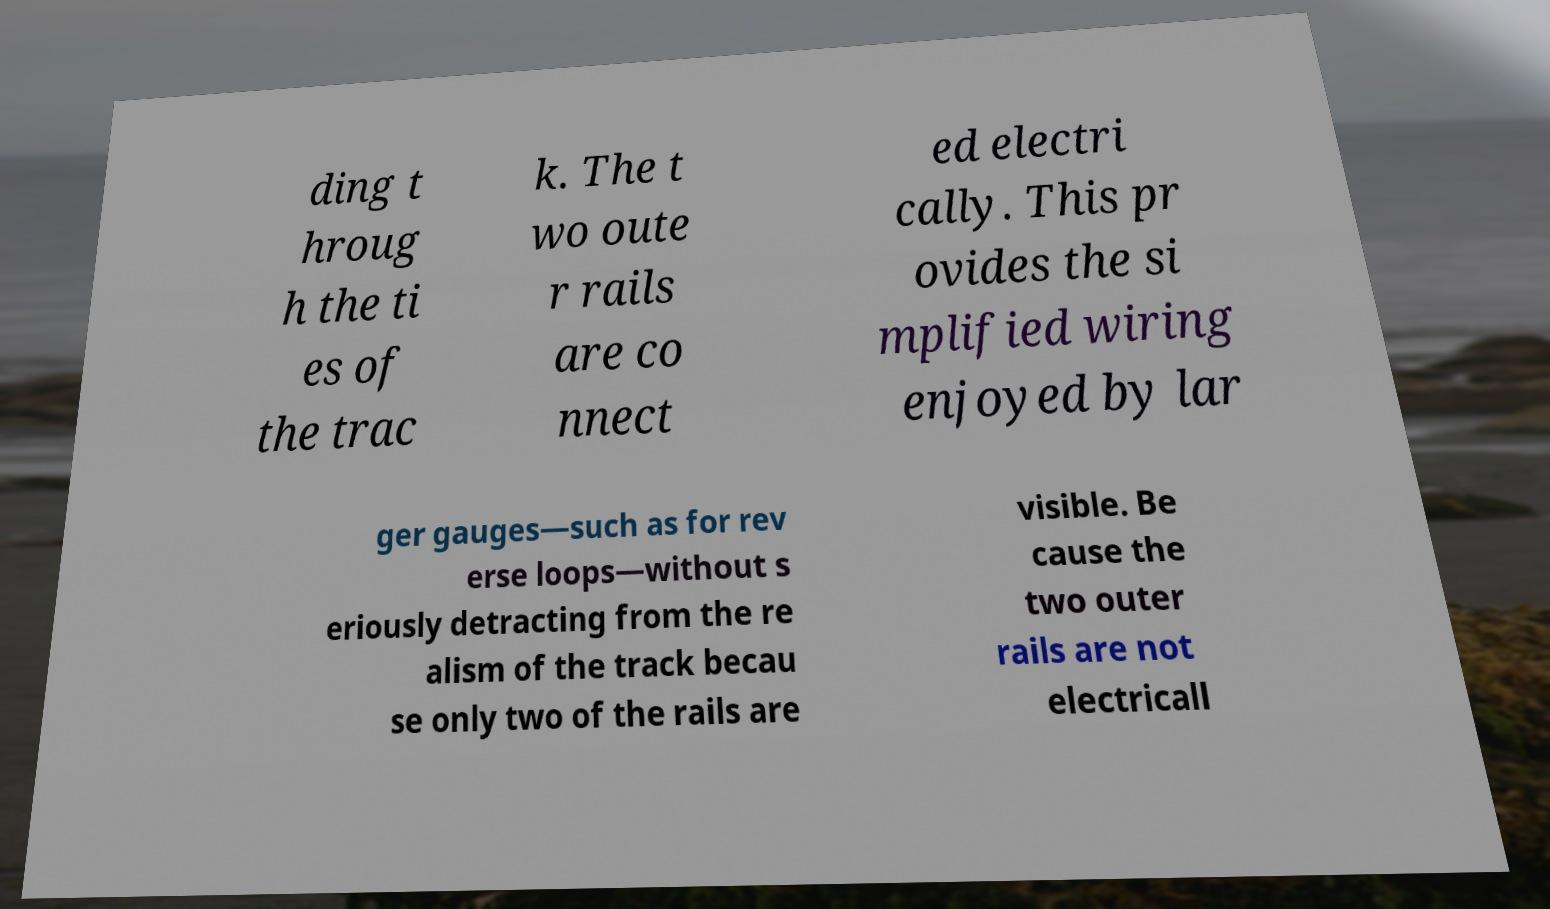I need the written content from this picture converted into text. Can you do that? ding t hroug h the ti es of the trac k. The t wo oute r rails are co nnect ed electri cally. This pr ovides the si mplified wiring enjoyed by lar ger gauges—such as for rev erse loops—without s eriously detracting from the re alism of the track becau se only two of the rails are visible. Be cause the two outer rails are not electricall 